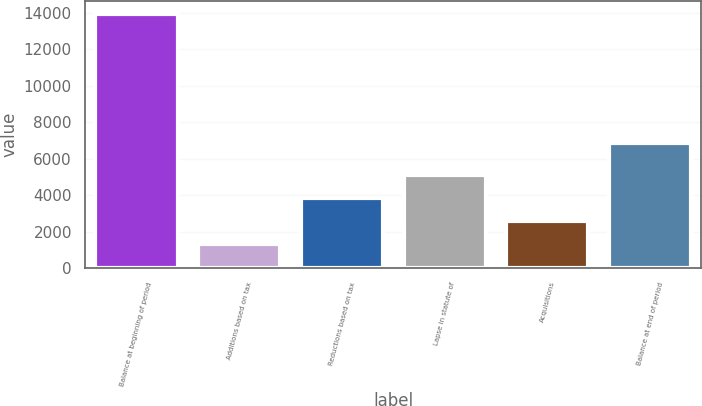Convert chart. <chart><loc_0><loc_0><loc_500><loc_500><bar_chart><fcel>Balance at beginning of period<fcel>Additions based on tax<fcel>Reductions based on tax<fcel>Lapse in statute of<fcel>Acquisitions<fcel>Balance at end of period<nl><fcel>13951<fcel>1304<fcel>3833.4<fcel>5098.1<fcel>2568.7<fcel>6859<nl></chart> 